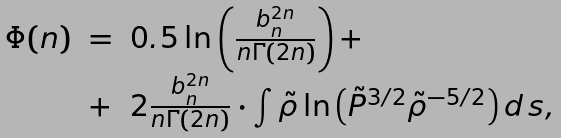<formula> <loc_0><loc_0><loc_500><loc_500>\begin{array} { l l l } \Phi ( n ) & = & 0 . 5 \ln \left ( \frac { b _ { n } ^ { 2 n } } { n \Gamma ( 2 n ) } \right ) + \\ & + & 2 \frac { b _ { n } ^ { 2 n } } { n \Gamma ( 2 n ) } \cdot \int \tilde { \rho } \ln \left ( \tilde { P } ^ { 3 / 2 } \tilde { \rho } ^ { - 5 / 2 } \right ) d \, s , \end{array}</formula> 